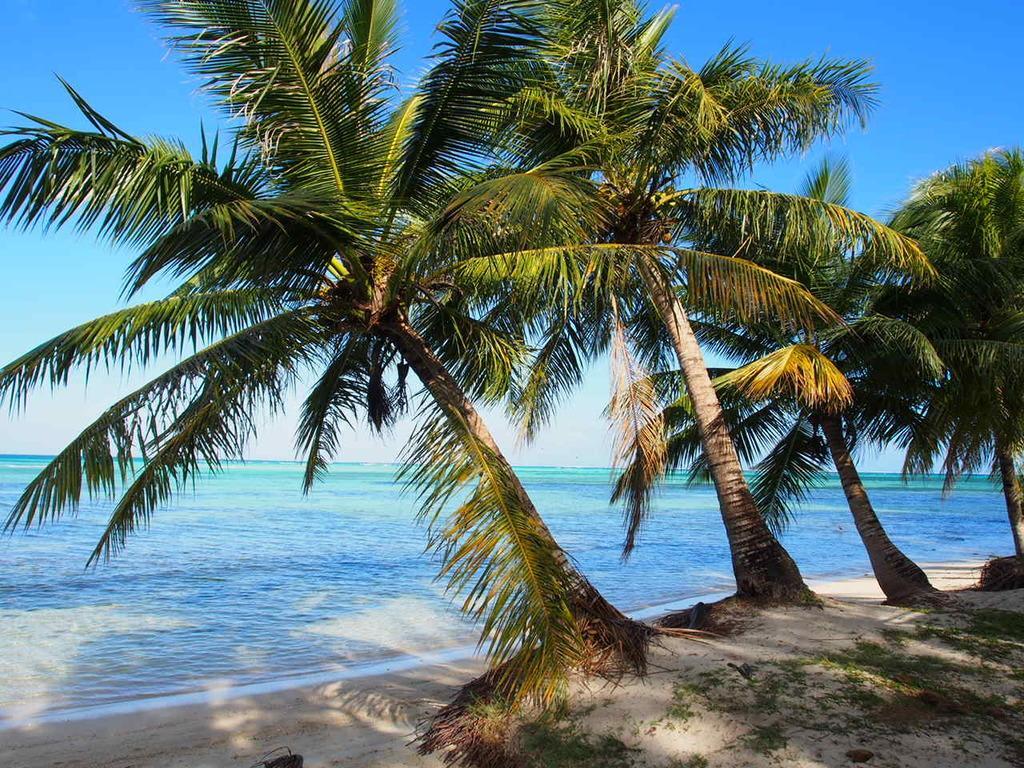Please provide a concise description of this image. In this picture we can observe trees in the beach. In the background there is an ocean and a sky. 